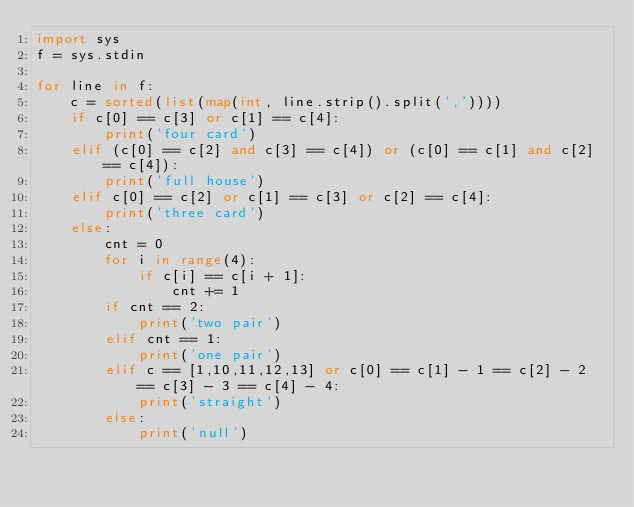Convert code to text. <code><loc_0><loc_0><loc_500><loc_500><_Python_>import sys
f = sys.stdin

for line in f:
    c = sorted(list(map(int, line.strip().split(','))))
    if c[0] == c[3] or c[1] == c[4]:
        print('four card')
    elif (c[0] == c[2] and c[3] == c[4]) or (c[0] == c[1] and c[2] == c[4]):
        print('full house')
    elif c[0] == c[2] or c[1] == c[3] or c[2] == c[4]:
        print('three card')
    else:
        cnt = 0
        for i in range(4):
            if c[i] == c[i + 1]:
                cnt += 1
        if cnt == 2:
            print('two pair')
        elif cnt == 1:
            print('one pair')
        elif c == [1,10,11,12,13] or c[0] == c[1] - 1 == c[2] - 2 == c[3] - 3 == c[4] - 4:
            print('straight')
        else:
            print('null')</code> 